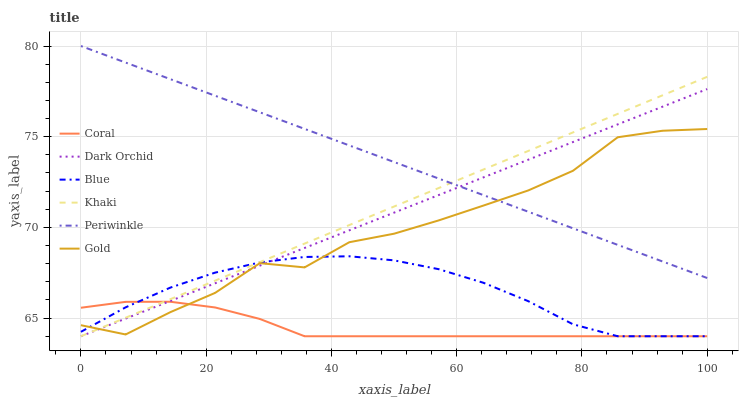Does Khaki have the minimum area under the curve?
Answer yes or no. No. Does Khaki have the maximum area under the curve?
Answer yes or no. No. Is Gold the smoothest?
Answer yes or no. No. Is Khaki the roughest?
Answer yes or no. No. Does Gold have the lowest value?
Answer yes or no. No. Does Khaki have the highest value?
Answer yes or no. No. Is Coral less than Periwinkle?
Answer yes or no. Yes. Is Periwinkle greater than Blue?
Answer yes or no. Yes. Does Coral intersect Periwinkle?
Answer yes or no. No. 